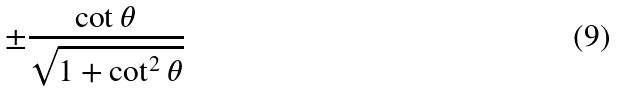<formula> <loc_0><loc_0><loc_500><loc_500>\pm { \frac { \cot \theta } { \sqrt { 1 + \cot ^ { 2 } \theta } } }</formula> 